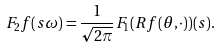Convert formula to latex. <formula><loc_0><loc_0><loc_500><loc_500>F _ { 2 } f ( s \omega ) = \frac { 1 } { \sqrt { 2 \pi } } F _ { 1 } ( R f ( \theta , \cdot ) ) ( s ) .</formula> 